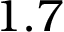<formula> <loc_0><loc_0><loc_500><loc_500>1 . 7</formula> 